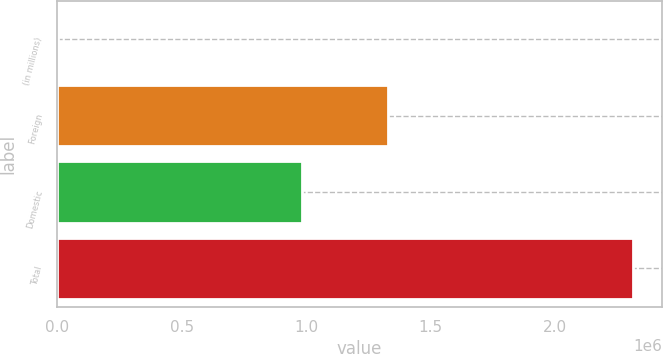<chart> <loc_0><loc_0><loc_500><loc_500><bar_chart><fcel>(in millions)<fcel>Foreign<fcel>Domestic<fcel>Total<nl><fcel>2007<fcel>1.32725e+06<fcel>984794<fcel>2.31204e+06<nl></chart> 